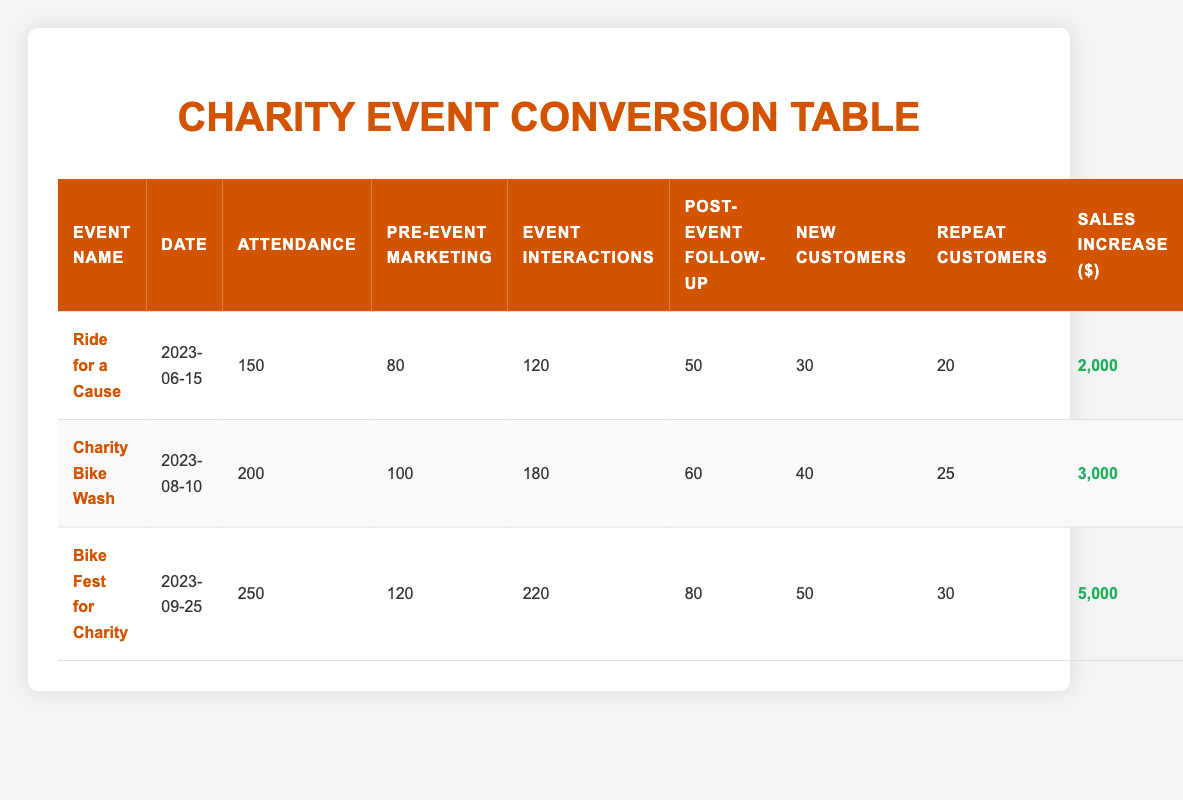What was the attendance for the "Charity Bike Wash"? The "Charity Bike Wash" has an attendance of 200, as directly stated in the attendance column for that event.
Answer: 200 How many new customers were gained from the "Bike Fest for Charity"? The "Bike Fest for Charity" gained 50 new customers, as recorded in the new customers column for that event.
Answer: 50 Which event had the highest sales increase? The event with the highest sales increase is "Bike Fest for Charity," showing an increase of $5,000 in the sales increase column.
Answer: 5,000 What is the total number of event interactions from all the charity events combined? To calculate the total number of event interactions, sum all interactions: 120 (Ride for a Cause) + 180 (Charity Bike Wash) + 220 (Bike Fest for Charity) = 520.
Answer: 520 Did "Ride for a Cause" have more post-event follow-ups than "Charity Bike Wash"? The "Ride for a Cause" had 50 post-event follow-ups, while the "Charity Bike Wash" had 60. Therefore, the statement is false.
Answer: No What is the average number of repeat customers across all events? To find the average, add the repeat customers: 20 (Ride for a Cause) + 25 (Charity Bike Wash) + 30 (Bike Fest for Charity) = 75, then divide by the number of events: 75/3 = 25.
Answer: 25 Which event had the highest ratio of new customers to attendance? Calculate the ratio for each event: 
- Ride for a Cause: 30 new customers / 150 attendance = 0.2 
- Charity Bike Wash: 40 new customers / 200 attendance = 0.2 
- Bike Fest for Charity: 50 new customers / 250 attendance = 0.2 
All events have the same ratio of 0.2, so there is no single highest.
Answer: All are equal Was the total attendance for the three events over 500? Add the attendance for all three events: 150 (Ride for a Cause) + 200 (Charity Bike Wash) + 250 (Bike Fest for Charity) = 600, which exceeds 500. Therefore, this statement is true.
Answer: Yes What is the difference in post-event follow-ups between the highest and lowest attended events? The highest attended event is "Bike Fest for Charity" with 80 post-event follow-ups and the lowest is "Ride for a Cause" with 50. The difference is 80 - 50 = 30.
Answer: 30 